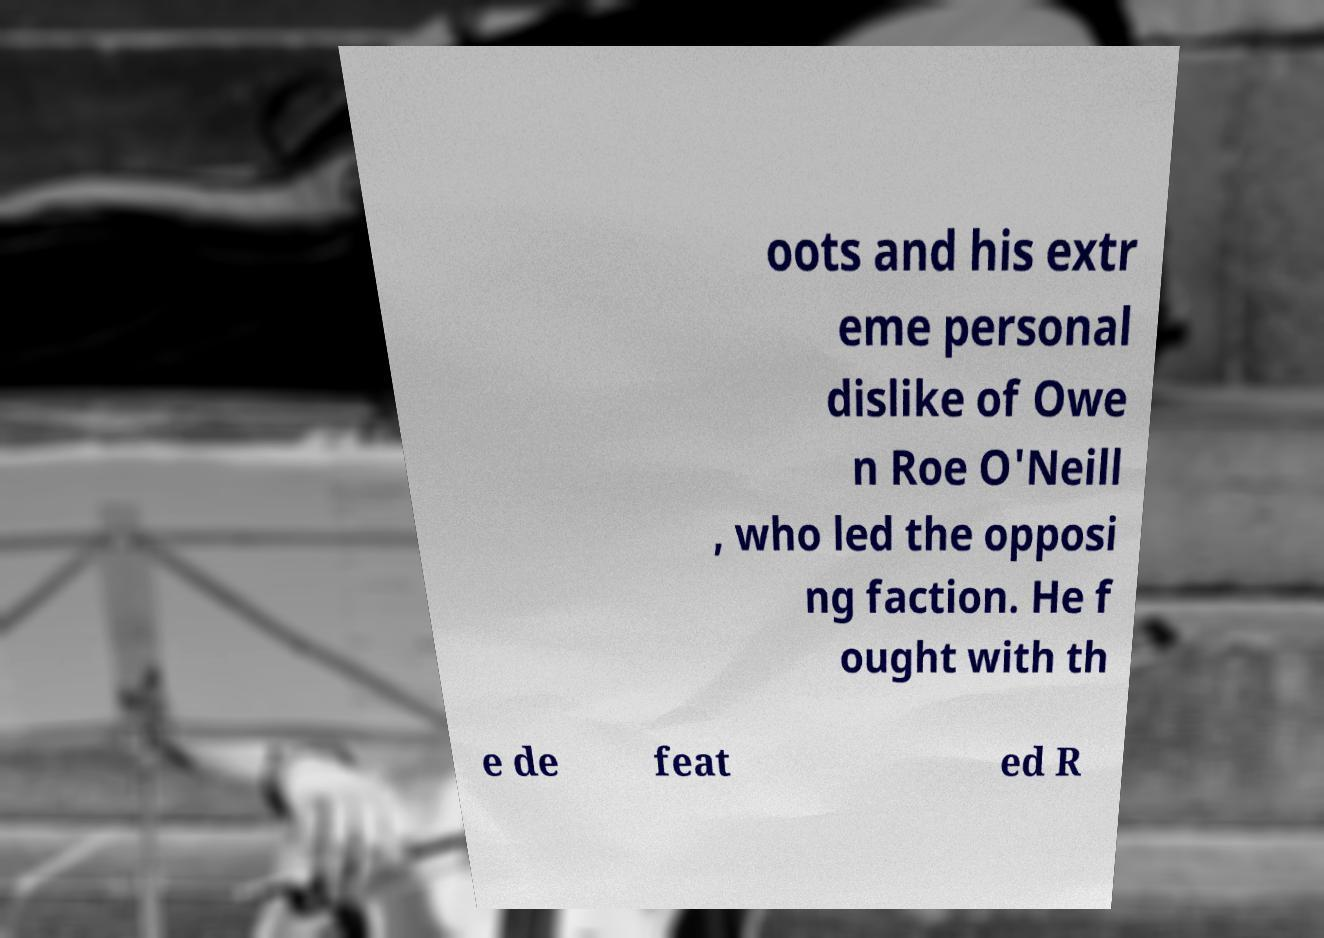There's text embedded in this image that I need extracted. Can you transcribe it verbatim? oots and his extr eme personal dislike of Owe n Roe O'Neill , who led the opposi ng faction. He f ought with th e de feat ed R 